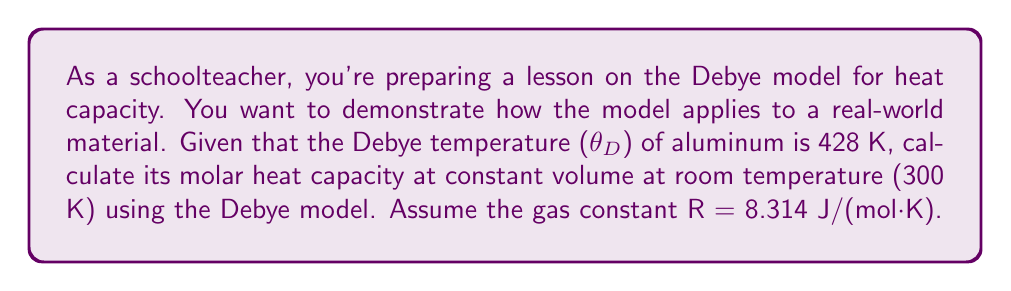Help me with this question. To solve this problem, we'll use the Debye model for the heat capacity of a solid. The steps are as follows:

1) The Debye model gives the molar heat capacity at constant volume as:

   $$C_V = 9R \left(\frac{T}{\theta_D}\right)^3 \int_0^{\theta_D/T} \frac{x^4e^x}{(e^x-1)^2} dx$$

   where R is the gas constant, T is the temperature, and $\theta_D$ is the Debye temperature.

2) We're given:
   - $\theta_D = 428$ K
   - $T = 300$ K
   - $R = 8.314$ J/(mol·K)

3) Let's calculate $\frac{\theta_D}{T}$:
   
   $$\frac{\theta_D}{T} = \frac{428}{300} = 1.427$$

4) Now we need to evaluate the integral:

   $$\int_0^{1.427} \frac{x^4e^x}{(e^x-1)^2} dx$$

   This integral doesn't have a simple analytical solution, so we typically use numerical methods or pre-calculated tables. For this temperature ratio, the value of the integral is approximately 0.8317.

5) Now we can calculate $C_V$:

   $$C_V = 9 \cdot 8.314 \cdot \left(\frac{300}{428}\right)^3 \cdot 0.8317$$

6) Simplifying:

   $$C_V = 74.826 \cdot 0.3439 \cdot 0.8317 = 21.4 \text{ J/(mol·K)}$$

Therefore, the molar heat capacity of aluminum at 300 K is approximately 21.4 J/(mol·K).
Answer: 21.4 J/(mol·K) 